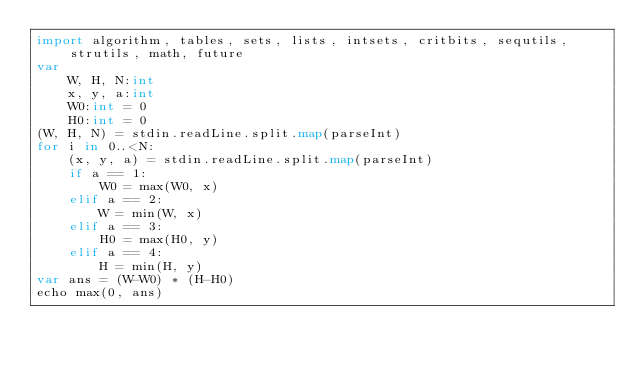Convert code to text. <code><loc_0><loc_0><loc_500><loc_500><_Nim_>import algorithm, tables, sets, lists, intsets, critbits, sequtils, strutils, math, future
var
    W, H, N:int
    x, y, a:int
    W0:int = 0
    H0:int = 0
(W, H, N) = stdin.readLine.split.map(parseInt)
for i in 0..<N:
    (x, y, a) = stdin.readLine.split.map(parseInt)
    if a == 1:
        W0 = max(W0, x)
    elif a == 2:
        W = min(W, x)
    elif a == 3:
        H0 = max(H0, y)
    elif a == 4:
        H = min(H, y)
var ans = (W-W0) * (H-H0)
echo max(0, ans)</code> 